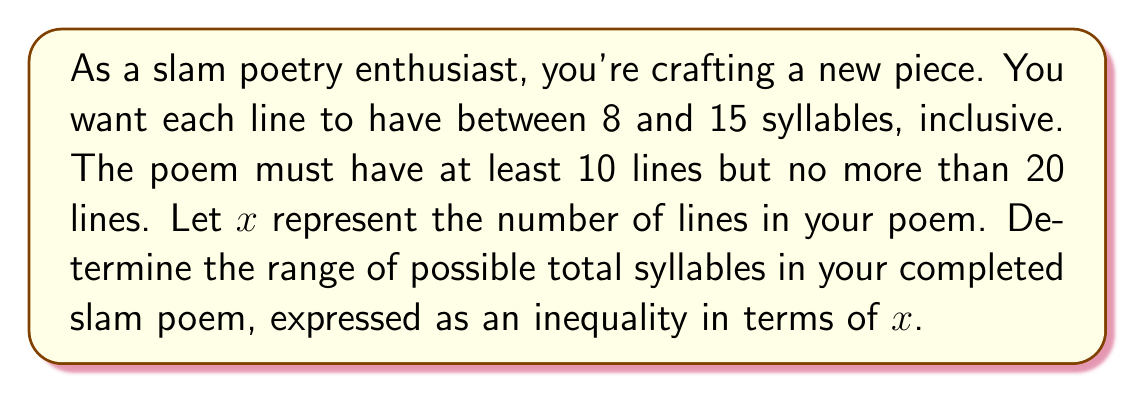Show me your answer to this math problem. Let's approach this step-by-step:

1) First, we need to establish the constraints on $x$:
   $10 \leq x \leq 20$

2) Now, let's consider the minimum number of syllables per line (8) and the maximum (15):
   - Minimum total syllables: $8x$
   - Maximum total syllables: $15x$

3) We can express this as a compound inequality:
   $8x \leq \text{total syllables} \leq 15x$

4) However, we need to consider the constraints on $x$ as well. Let's substitute the minimum and maximum values of $x$:

   For $x = 10$ (minimum lines):
   $8(10) \leq \text{total syllables} \leq 15(10)$
   $80 \leq \text{total syllables} \leq 150$

   For $x = 20$ (maximum lines):
   $8(20) \leq \text{total syllables} \leq 15(20)$
   $160 \leq \text{total syllables} \leq 300$

5) Combining these results, we get the final range:
   $80 \leq \text{total syllables} \leq 300$

This inequality represents all possible total syllable counts for poems satisfying the given constraints.
Answer: $80 \leq \text{total syllables} \leq 300$ 